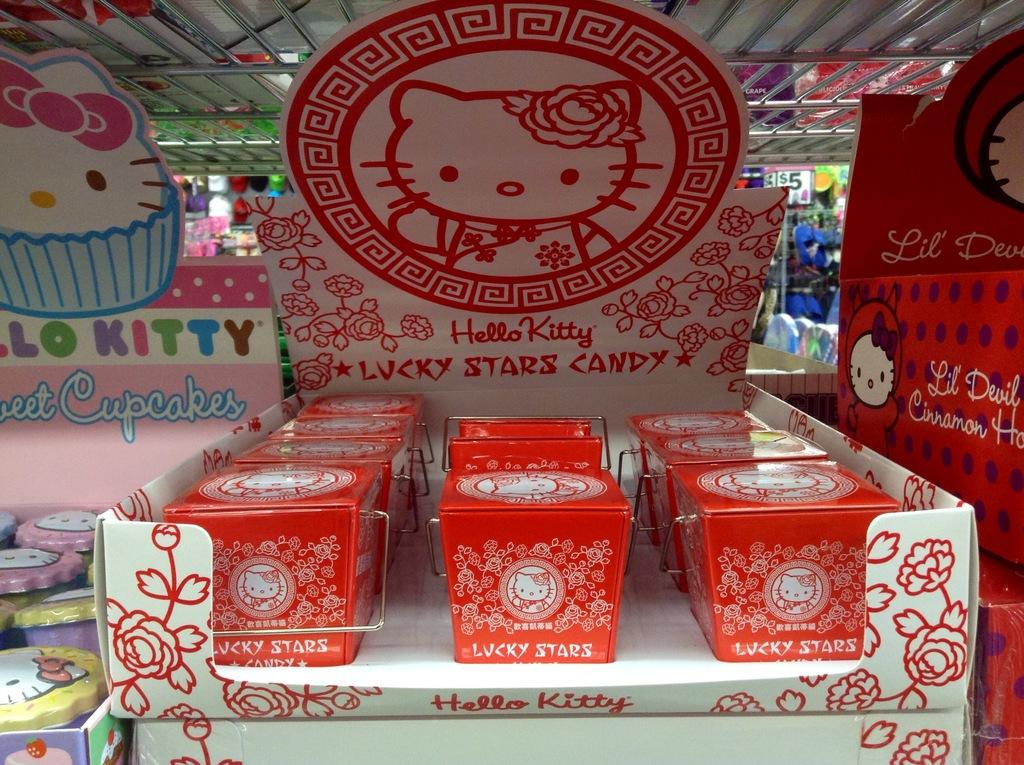<image>
Provide a brief description of the given image. A display of Hello Kitty Lucky Stars Candy sits on a shelf. 